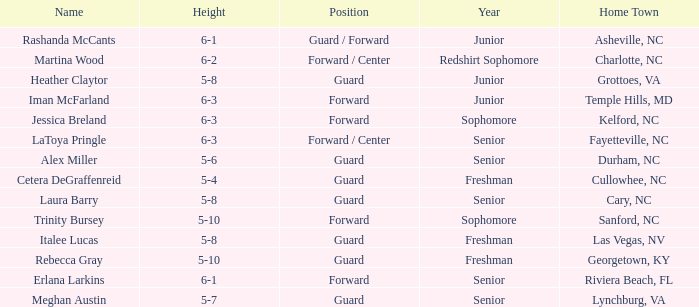In what year of school is the forward Iman McFarland? Junior. 